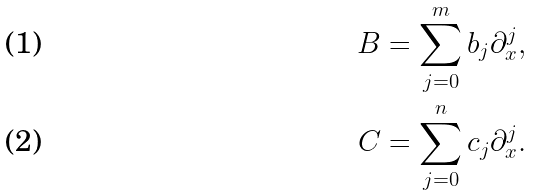<formula> <loc_0><loc_0><loc_500><loc_500>B & = \sum _ { j = 0 } ^ { m } b _ { j } \partial _ { x } ^ { j } , \\ C & = \sum _ { j = 0 } ^ { n } c _ { j } \partial _ { x } ^ { j } .</formula> 